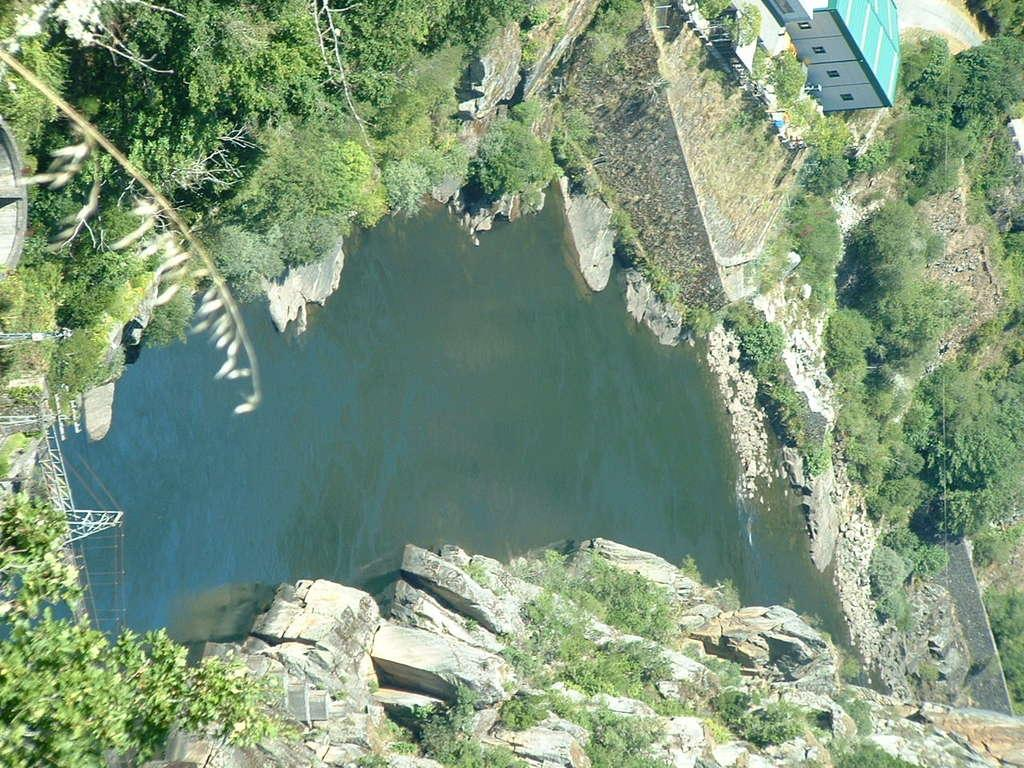What is the primary element present in the image? There is water in the image. What other natural elements can be seen in the image? There are stones, trees, and rocks visible in the image. Are there any man-made structures in the image? Yes, there is a bridge and a house in the image. What type of pathway is present in the image? There is a road in the image. What is the fifth statement made by the water in the image? The water in the image does not make any statements, as it is an inanimate object. 